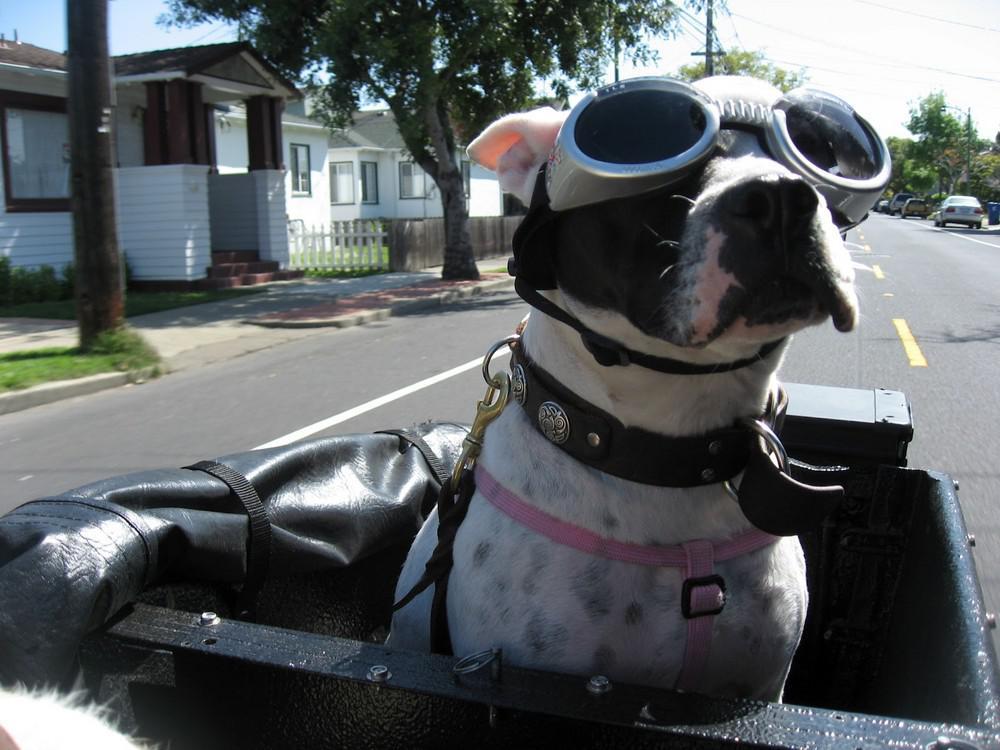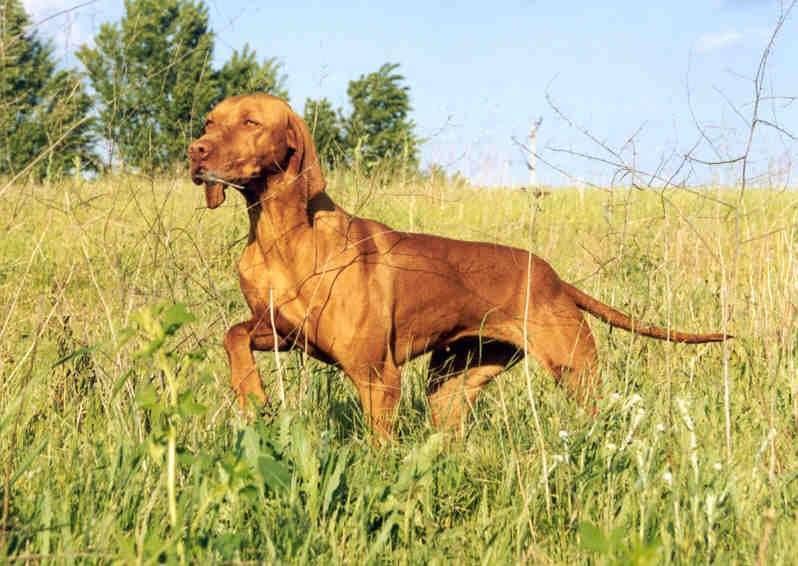The first image is the image on the left, the second image is the image on the right. Assess this claim about the two images: "The left image shows a red dog sitting in a white side car of a motorcycle without a driver on the seat.". Correct or not? Answer yes or no. No. The first image is the image on the left, the second image is the image on the right. Examine the images to the left and right. Is the description "The white motorbike has a dog passenger but no driver." accurate? Answer yes or no. No. 